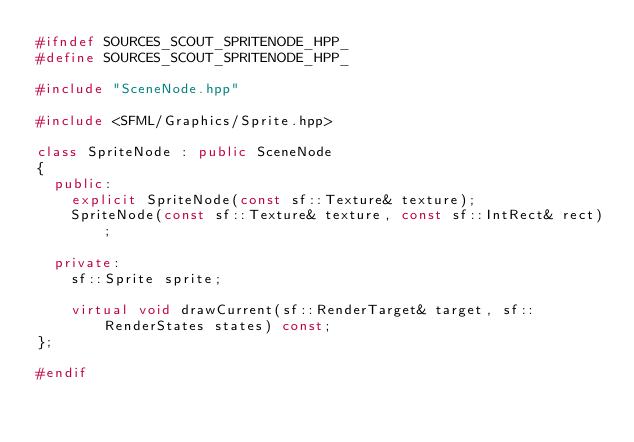<code> <loc_0><loc_0><loc_500><loc_500><_C++_>#ifndef SOURCES_SCOUT_SPRITENODE_HPP_
#define SOURCES_SCOUT_SPRITENODE_HPP_

#include "SceneNode.hpp"

#include <SFML/Graphics/Sprite.hpp>

class SpriteNode : public SceneNode
{
  public:
    explicit SpriteNode(const sf::Texture& texture);
    SpriteNode(const sf::Texture& texture, const sf::IntRect& rect);

  private:
    sf::Sprite sprite;

    virtual void drawCurrent(sf::RenderTarget& target, sf::RenderStates states) const;
};

#endif
</code> 